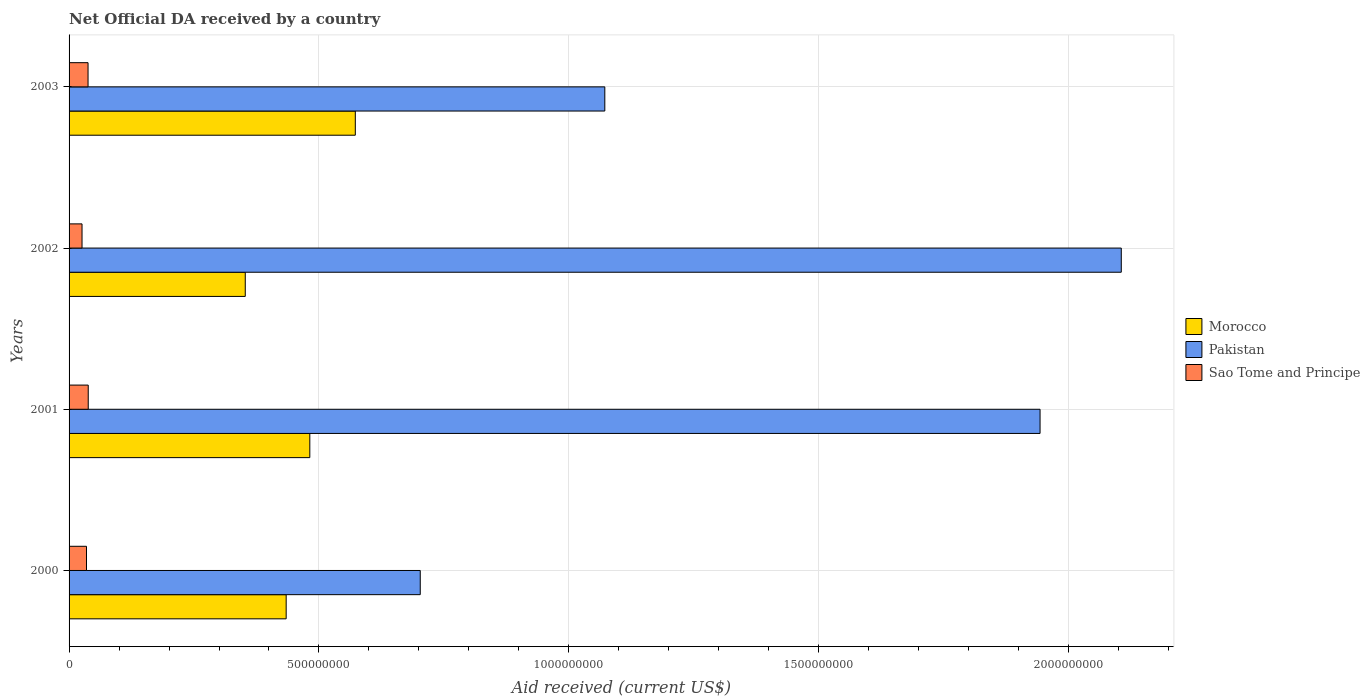How many groups of bars are there?
Keep it short and to the point. 4. Are the number of bars per tick equal to the number of legend labels?
Make the answer very short. Yes. Are the number of bars on each tick of the Y-axis equal?
Ensure brevity in your answer.  Yes. What is the label of the 2nd group of bars from the top?
Provide a succinct answer. 2002. In how many cases, is the number of bars for a given year not equal to the number of legend labels?
Provide a short and direct response. 0. What is the net official development assistance aid received in Morocco in 2002?
Your response must be concise. 3.53e+08. Across all years, what is the maximum net official development assistance aid received in Pakistan?
Give a very brief answer. 2.11e+09. Across all years, what is the minimum net official development assistance aid received in Morocco?
Offer a terse response. 3.53e+08. In which year was the net official development assistance aid received in Morocco maximum?
Provide a succinct answer. 2003. In which year was the net official development assistance aid received in Pakistan minimum?
Offer a terse response. 2000. What is the total net official development assistance aid received in Pakistan in the graph?
Your answer should be compact. 5.82e+09. What is the difference between the net official development assistance aid received in Sao Tome and Principe in 2001 and that in 2003?
Your answer should be compact. 3.80e+05. What is the difference between the net official development assistance aid received in Pakistan in 2001 and the net official development assistance aid received in Morocco in 2002?
Make the answer very short. 1.59e+09. What is the average net official development assistance aid received in Morocco per year?
Provide a succinct answer. 4.60e+08. In the year 2001, what is the difference between the net official development assistance aid received in Morocco and net official development assistance aid received in Sao Tome and Principe?
Offer a very short reply. 4.43e+08. In how many years, is the net official development assistance aid received in Pakistan greater than 700000000 US$?
Your answer should be very brief. 4. What is the ratio of the net official development assistance aid received in Morocco in 2002 to that in 2003?
Offer a terse response. 0.62. Is the net official development assistance aid received in Morocco in 2001 less than that in 2003?
Provide a short and direct response. Yes. Is the difference between the net official development assistance aid received in Morocco in 2000 and 2002 greater than the difference between the net official development assistance aid received in Sao Tome and Principe in 2000 and 2002?
Offer a terse response. Yes. What is the difference between the highest and the lowest net official development assistance aid received in Pakistan?
Give a very brief answer. 1.40e+09. In how many years, is the net official development assistance aid received in Morocco greater than the average net official development assistance aid received in Morocco taken over all years?
Your answer should be compact. 2. What does the 2nd bar from the top in 2001 represents?
Provide a succinct answer. Pakistan. What is the difference between two consecutive major ticks on the X-axis?
Provide a short and direct response. 5.00e+08. Are the values on the major ticks of X-axis written in scientific E-notation?
Provide a succinct answer. No. Does the graph contain any zero values?
Provide a short and direct response. No. Does the graph contain grids?
Your response must be concise. Yes. How many legend labels are there?
Provide a short and direct response. 3. What is the title of the graph?
Provide a succinct answer. Net Official DA received by a country. What is the label or title of the X-axis?
Offer a very short reply. Aid received (current US$). What is the Aid received (current US$) of Morocco in 2000?
Your answer should be compact. 4.34e+08. What is the Aid received (current US$) of Pakistan in 2000?
Offer a terse response. 7.03e+08. What is the Aid received (current US$) in Sao Tome and Principe in 2000?
Your answer should be compact. 3.49e+07. What is the Aid received (current US$) of Morocco in 2001?
Provide a succinct answer. 4.82e+08. What is the Aid received (current US$) in Pakistan in 2001?
Your response must be concise. 1.94e+09. What is the Aid received (current US$) in Sao Tome and Principe in 2001?
Keep it short and to the point. 3.84e+07. What is the Aid received (current US$) of Morocco in 2002?
Provide a short and direct response. 3.53e+08. What is the Aid received (current US$) in Pakistan in 2002?
Give a very brief answer. 2.11e+09. What is the Aid received (current US$) in Sao Tome and Principe in 2002?
Keep it short and to the point. 2.59e+07. What is the Aid received (current US$) in Morocco in 2003?
Provide a short and direct response. 5.73e+08. What is the Aid received (current US$) of Pakistan in 2003?
Your response must be concise. 1.07e+09. What is the Aid received (current US$) of Sao Tome and Principe in 2003?
Provide a short and direct response. 3.80e+07. Across all years, what is the maximum Aid received (current US$) in Morocco?
Keep it short and to the point. 5.73e+08. Across all years, what is the maximum Aid received (current US$) of Pakistan?
Provide a succinct answer. 2.11e+09. Across all years, what is the maximum Aid received (current US$) in Sao Tome and Principe?
Provide a short and direct response. 3.84e+07. Across all years, what is the minimum Aid received (current US$) in Morocco?
Offer a very short reply. 3.53e+08. Across all years, what is the minimum Aid received (current US$) in Pakistan?
Your response must be concise. 7.03e+08. Across all years, what is the minimum Aid received (current US$) in Sao Tome and Principe?
Make the answer very short. 2.59e+07. What is the total Aid received (current US$) of Morocco in the graph?
Offer a very short reply. 1.84e+09. What is the total Aid received (current US$) of Pakistan in the graph?
Your answer should be compact. 5.82e+09. What is the total Aid received (current US$) in Sao Tome and Principe in the graph?
Provide a succinct answer. 1.37e+08. What is the difference between the Aid received (current US$) in Morocco in 2000 and that in 2001?
Your response must be concise. -4.73e+07. What is the difference between the Aid received (current US$) of Pakistan in 2000 and that in 2001?
Your answer should be compact. -1.24e+09. What is the difference between the Aid received (current US$) of Sao Tome and Principe in 2000 and that in 2001?
Ensure brevity in your answer.  -3.47e+06. What is the difference between the Aid received (current US$) in Morocco in 2000 and that in 2002?
Your response must be concise. 8.18e+07. What is the difference between the Aid received (current US$) in Pakistan in 2000 and that in 2002?
Make the answer very short. -1.40e+09. What is the difference between the Aid received (current US$) of Sao Tome and Principe in 2000 and that in 2002?
Provide a short and direct response. 8.97e+06. What is the difference between the Aid received (current US$) in Morocco in 2000 and that in 2003?
Ensure brevity in your answer.  -1.38e+08. What is the difference between the Aid received (current US$) in Pakistan in 2000 and that in 2003?
Offer a very short reply. -3.69e+08. What is the difference between the Aid received (current US$) of Sao Tome and Principe in 2000 and that in 2003?
Offer a terse response. -3.09e+06. What is the difference between the Aid received (current US$) in Morocco in 2001 and that in 2002?
Provide a succinct answer. 1.29e+08. What is the difference between the Aid received (current US$) in Pakistan in 2001 and that in 2002?
Offer a terse response. -1.63e+08. What is the difference between the Aid received (current US$) of Sao Tome and Principe in 2001 and that in 2002?
Your response must be concise. 1.24e+07. What is the difference between the Aid received (current US$) of Morocco in 2001 and that in 2003?
Your response must be concise. -9.10e+07. What is the difference between the Aid received (current US$) of Pakistan in 2001 and that in 2003?
Make the answer very short. 8.71e+08. What is the difference between the Aid received (current US$) in Morocco in 2002 and that in 2003?
Offer a terse response. -2.20e+08. What is the difference between the Aid received (current US$) of Pakistan in 2002 and that in 2003?
Offer a very short reply. 1.03e+09. What is the difference between the Aid received (current US$) of Sao Tome and Principe in 2002 and that in 2003?
Provide a short and direct response. -1.21e+07. What is the difference between the Aid received (current US$) in Morocco in 2000 and the Aid received (current US$) in Pakistan in 2001?
Ensure brevity in your answer.  -1.51e+09. What is the difference between the Aid received (current US$) of Morocco in 2000 and the Aid received (current US$) of Sao Tome and Principe in 2001?
Keep it short and to the point. 3.96e+08. What is the difference between the Aid received (current US$) of Pakistan in 2000 and the Aid received (current US$) of Sao Tome and Principe in 2001?
Your answer should be compact. 6.64e+08. What is the difference between the Aid received (current US$) of Morocco in 2000 and the Aid received (current US$) of Pakistan in 2002?
Keep it short and to the point. -1.67e+09. What is the difference between the Aid received (current US$) in Morocco in 2000 and the Aid received (current US$) in Sao Tome and Principe in 2002?
Your response must be concise. 4.08e+08. What is the difference between the Aid received (current US$) in Pakistan in 2000 and the Aid received (current US$) in Sao Tome and Principe in 2002?
Make the answer very short. 6.77e+08. What is the difference between the Aid received (current US$) in Morocco in 2000 and the Aid received (current US$) in Pakistan in 2003?
Offer a terse response. -6.38e+08. What is the difference between the Aid received (current US$) of Morocco in 2000 and the Aid received (current US$) of Sao Tome and Principe in 2003?
Make the answer very short. 3.96e+08. What is the difference between the Aid received (current US$) of Pakistan in 2000 and the Aid received (current US$) of Sao Tome and Principe in 2003?
Your answer should be very brief. 6.65e+08. What is the difference between the Aid received (current US$) in Morocco in 2001 and the Aid received (current US$) in Pakistan in 2002?
Ensure brevity in your answer.  -1.62e+09. What is the difference between the Aid received (current US$) in Morocco in 2001 and the Aid received (current US$) in Sao Tome and Principe in 2002?
Offer a very short reply. 4.56e+08. What is the difference between the Aid received (current US$) of Pakistan in 2001 and the Aid received (current US$) of Sao Tome and Principe in 2002?
Your answer should be very brief. 1.92e+09. What is the difference between the Aid received (current US$) in Morocco in 2001 and the Aid received (current US$) in Pakistan in 2003?
Your answer should be very brief. -5.90e+08. What is the difference between the Aid received (current US$) of Morocco in 2001 and the Aid received (current US$) of Sao Tome and Principe in 2003?
Your answer should be compact. 4.44e+08. What is the difference between the Aid received (current US$) of Pakistan in 2001 and the Aid received (current US$) of Sao Tome and Principe in 2003?
Give a very brief answer. 1.90e+09. What is the difference between the Aid received (current US$) in Morocco in 2002 and the Aid received (current US$) in Pakistan in 2003?
Make the answer very short. -7.19e+08. What is the difference between the Aid received (current US$) in Morocco in 2002 and the Aid received (current US$) in Sao Tome and Principe in 2003?
Provide a succinct answer. 3.15e+08. What is the difference between the Aid received (current US$) of Pakistan in 2002 and the Aid received (current US$) of Sao Tome and Principe in 2003?
Your answer should be very brief. 2.07e+09. What is the average Aid received (current US$) of Morocco per year?
Your answer should be compact. 4.60e+08. What is the average Aid received (current US$) in Pakistan per year?
Offer a very short reply. 1.46e+09. What is the average Aid received (current US$) in Sao Tome and Principe per year?
Your response must be concise. 3.43e+07. In the year 2000, what is the difference between the Aid received (current US$) in Morocco and Aid received (current US$) in Pakistan?
Make the answer very short. -2.68e+08. In the year 2000, what is the difference between the Aid received (current US$) of Morocco and Aid received (current US$) of Sao Tome and Principe?
Your response must be concise. 4.00e+08. In the year 2000, what is the difference between the Aid received (current US$) in Pakistan and Aid received (current US$) in Sao Tome and Principe?
Your answer should be very brief. 6.68e+08. In the year 2001, what is the difference between the Aid received (current US$) in Morocco and Aid received (current US$) in Pakistan?
Your response must be concise. -1.46e+09. In the year 2001, what is the difference between the Aid received (current US$) of Morocco and Aid received (current US$) of Sao Tome and Principe?
Provide a short and direct response. 4.43e+08. In the year 2001, what is the difference between the Aid received (current US$) of Pakistan and Aid received (current US$) of Sao Tome and Principe?
Your answer should be very brief. 1.90e+09. In the year 2002, what is the difference between the Aid received (current US$) in Morocco and Aid received (current US$) in Pakistan?
Provide a succinct answer. -1.75e+09. In the year 2002, what is the difference between the Aid received (current US$) of Morocco and Aid received (current US$) of Sao Tome and Principe?
Your answer should be very brief. 3.27e+08. In the year 2002, what is the difference between the Aid received (current US$) of Pakistan and Aid received (current US$) of Sao Tome and Principe?
Give a very brief answer. 2.08e+09. In the year 2003, what is the difference between the Aid received (current US$) in Morocco and Aid received (current US$) in Pakistan?
Give a very brief answer. -4.99e+08. In the year 2003, what is the difference between the Aid received (current US$) of Morocco and Aid received (current US$) of Sao Tome and Principe?
Offer a terse response. 5.35e+08. In the year 2003, what is the difference between the Aid received (current US$) in Pakistan and Aid received (current US$) in Sao Tome and Principe?
Keep it short and to the point. 1.03e+09. What is the ratio of the Aid received (current US$) of Morocco in 2000 to that in 2001?
Keep it short and to the point. 0.9. What is the ratio of the Aid received (current US$) of Pakistan in 2000 to that in 2001?
Provide a succinct answer. 0.36. What is the ratio of the Aid received (current US$) in Sao Tome and Principe in 2000 to that in 2001?
Ensure brevity in your answer.  0.91. What is the ratio of the Aid received (current US$) in Morocco in 2000 to that in 2002?
Offer a terse response. 1.23. What is the ratio of the Aid received (current US$) in Pakistan in 2000 to that in 2002?
Provide a succinct answer. 0.33. What is the ratio of the Aid received (current US$) of Sao Tome and Principe in 2000 to that in 2002?
Keep it short and to the point. 1.35. What is the ratio of the Aid received (current US$) in Morocco in 2000 to that in 2003?
Your response must be concise. 0.76. What is the ratio of the Aid received (current US$) in Pakistan in 2000 to that in 2003?
Offer a very short reply. 0.66. What is the ratio of the Aid received (current US$) of Sao Tome and Principe in 2000 to that in 2003?
Keep it short and to the point. 0.92. What is the ratio of the Aid received (current US$) of Morocco in 2001 to that in 2002?
Offer a terse response. 1.37. What is the ratio of the Aid received (current US$) in Pakistan in 2001 to that in 2002?
Offer a terse response. 0.92. What is the ratio of the Aid received (current US$) of Sao Tome and Principe in 2001 to that in 2002?
Provide a succinct answer. 1.48. What is the ratio of the Aid received (current US$) in Morocco in 2001 to that in 2003?
Your response must be concise. 0.84. What is the ratio of the Aid received (current US$) in Pakistan in 2001 to that in 2003?
Make the answer very short. 1.81. What is the ratio of the Aid received (current US$) in Sao Tome and Principe in 2001 to that in 2003?
Keep it short and to the point. 1.01. What is the ratio of the Aid received (current US$) of Morocco in 2002 to that in 2003?
Your response must be concise. 0.62. What is the ratio of the Aid received (current US$) of Pakistan in 2002 to that in 2003?
Your response must be concise. 1.96. What is the ratio of the Aid received (current US$) of Sao Tome and Principe in 2002 to that in 2003?
Your answer should be very brief. 0.68. What is the difference between the highest and the second highest Aid received (current US$) of Morocco?
Keep it short and to the point. 9.10e+07. What is the difference between the highest and the second highest Aid received (current US$) in Pakistan?
Provide a succinct answer. 1.63e+08. What is the difference between the highest and the lowest Aid received (current US$) in Morocco?
Give a very brief answer. 2.20e+08. What is the difference between the highest and the lowest Aid received (current US$) in Pakistan?
Give a very brief answer. 1.40e+09. What is the difference between the highest and the lowest Aid received (current US$) of Sao Tome and Principe?
Provide a short and direct response. 1.24e+07. 